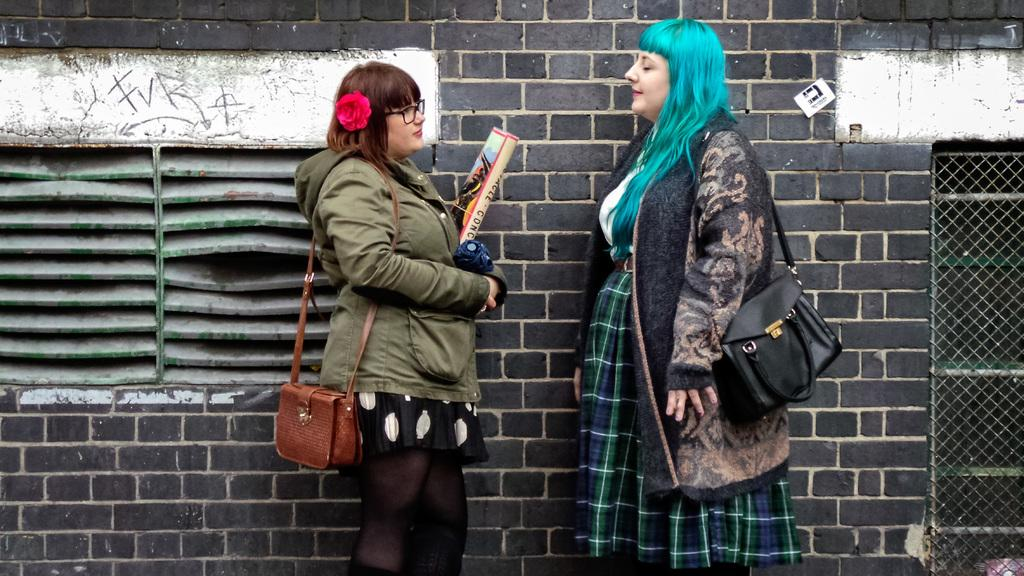How many people are present in the image? There are two women in the image. What are the women doing in the image? The women are talking to each other. What type of dolls can be seen in the image? There are no dolls present in the image; it features two women talking to each other. What is the texture of the feather in the image? There is no feather present in the image. 